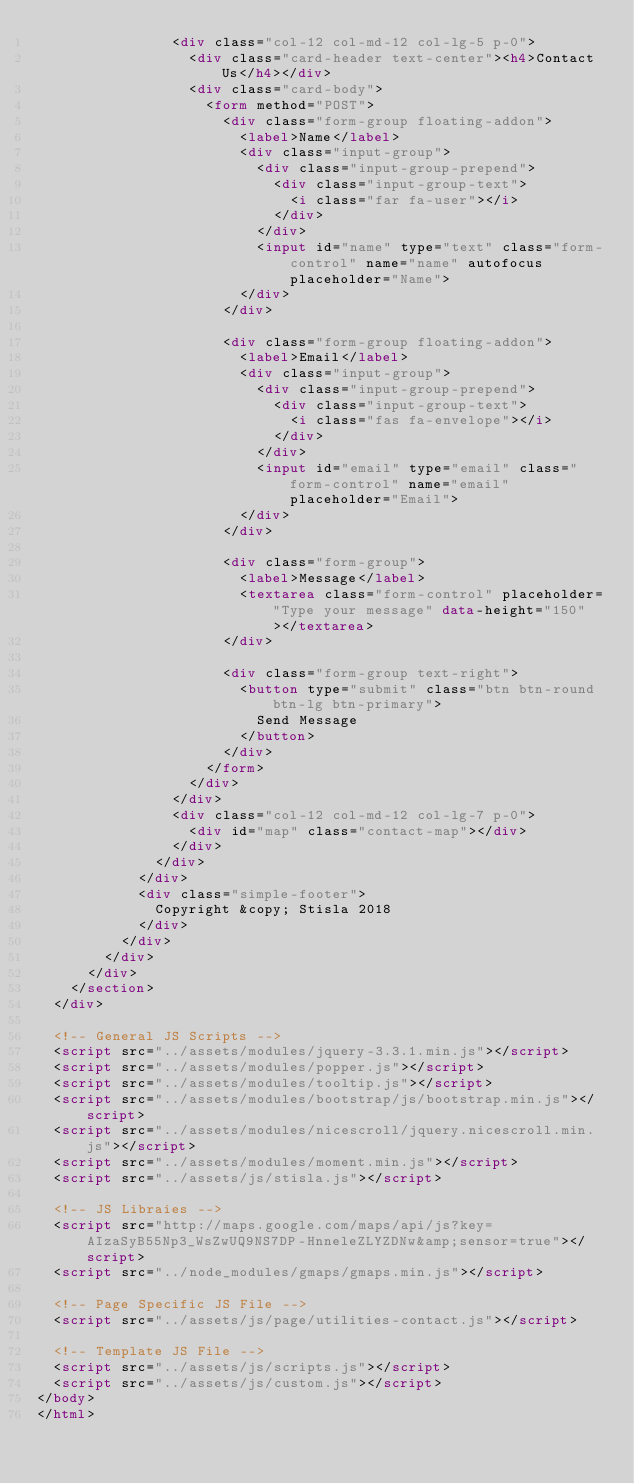<code> <loc_0><loc_0><loc_500><loc_500><_HTML_>                <div class="col-12 col-md-12 col-lg-5 p-0">
                  <div class="card-header text-center"><h4>Contact Us</h4></div>
                  <div class="card-body">
                    <form method="POST">
                      <div class="form-group floating-addon">
                        <label>Name</label>
                        <div class="input-group">
                          <div class="input-group-prepend">
                            <div class="input-group-text">
                              <i class="far fa-user"></i>
                            </div>
                          </div>
                          <input id="name" type="text" class="form-control" name="name" autofocus placeholder="Name">
                        </div>
                      </div>

                      <div class="form-group floating-addon">
                        <label>Email</label>
                        <div class="input-group">
                          <div class="input-group-prepend">
                            <div class="input-group-text">
                              <i class="fas fa-envelope"></i>
                            </div>
                          </div>
                          <input id="email" type="email" class="form-control" name="email" placeholder="Email">
                        </div>
                      </div>

                      <div class="form-group">
                        <label>Message</label>
                        <textarea class="form-control" placeholder="Type your message" data-height="150"></textarea>
                      </div>

                      <div class="form-group text-right">
                        <button type="submit" class="btn btn-round btn-lg btn-primary">
                          Send Message
                        </button>
                      </div>
                    </form>
                  </div>
                </div>
                <div class="col-12 col-md-12 col-lg-7 p-0">
                  <div id="map" class="contact-map"></div>
                </div>
              </div>
            </div>
            <div class="simple-footer">
              Copyright &copy; Stisla 2018
            </div>
          </div>
        </div>
      </div>
    </section>
  </div>

  <!-- General JS Scripts -->
  <script src="../assets/modules/jquery-3.3.1.min.js"></script>
  <script src="../assets/modules/popper.js"></script>
  <script src="../assets/modules/tooltip.js"></script>
  <script src="../assets/modules/bootstrap/js/bootstrap.min.js"></script>
  <script src="../assets/modules/nicescroll/jquery.nicescroll.min.js"></script>
  <script src="../assets/modules/moment.min.js"></script>
  <script src="../assets/js/stisla.js"></script>

  <!-- JS Libraies -->
  <script src="http://maps.google.com/maps/api/js?key=AIzaSyB55Np3_WsZwUQ9NS7DP-HnneleZLYZDNw&amp;sensor=true"></script>
  <script src="../node_modules/gmaps/gmaps.min.js"></script>

  <!-- Page Specific JS File -->
  <script src="../assets/js/page/utilities-contact.js"></script>

  <!-- Template JS File -->
  <script src="../assets/js/scripts.js"></script>
  <script src="../assets/js/custom.js"></script>
</body>
</html>
</code> 